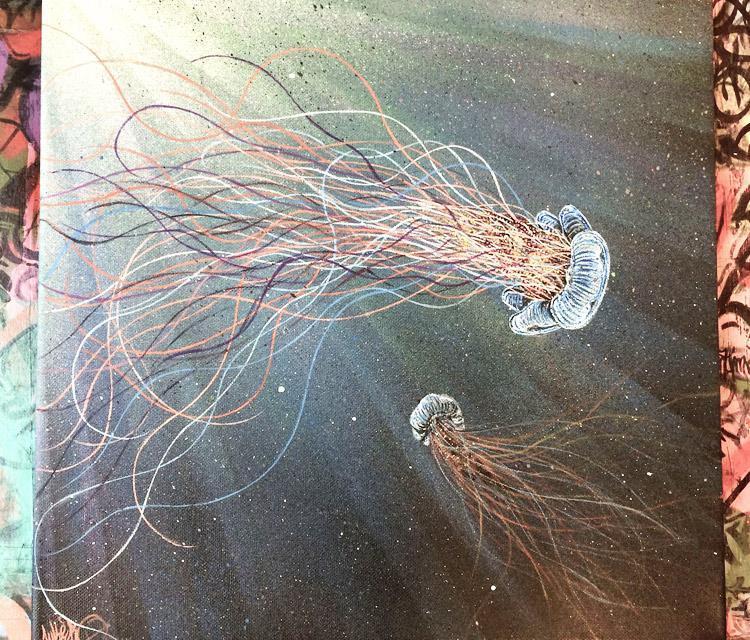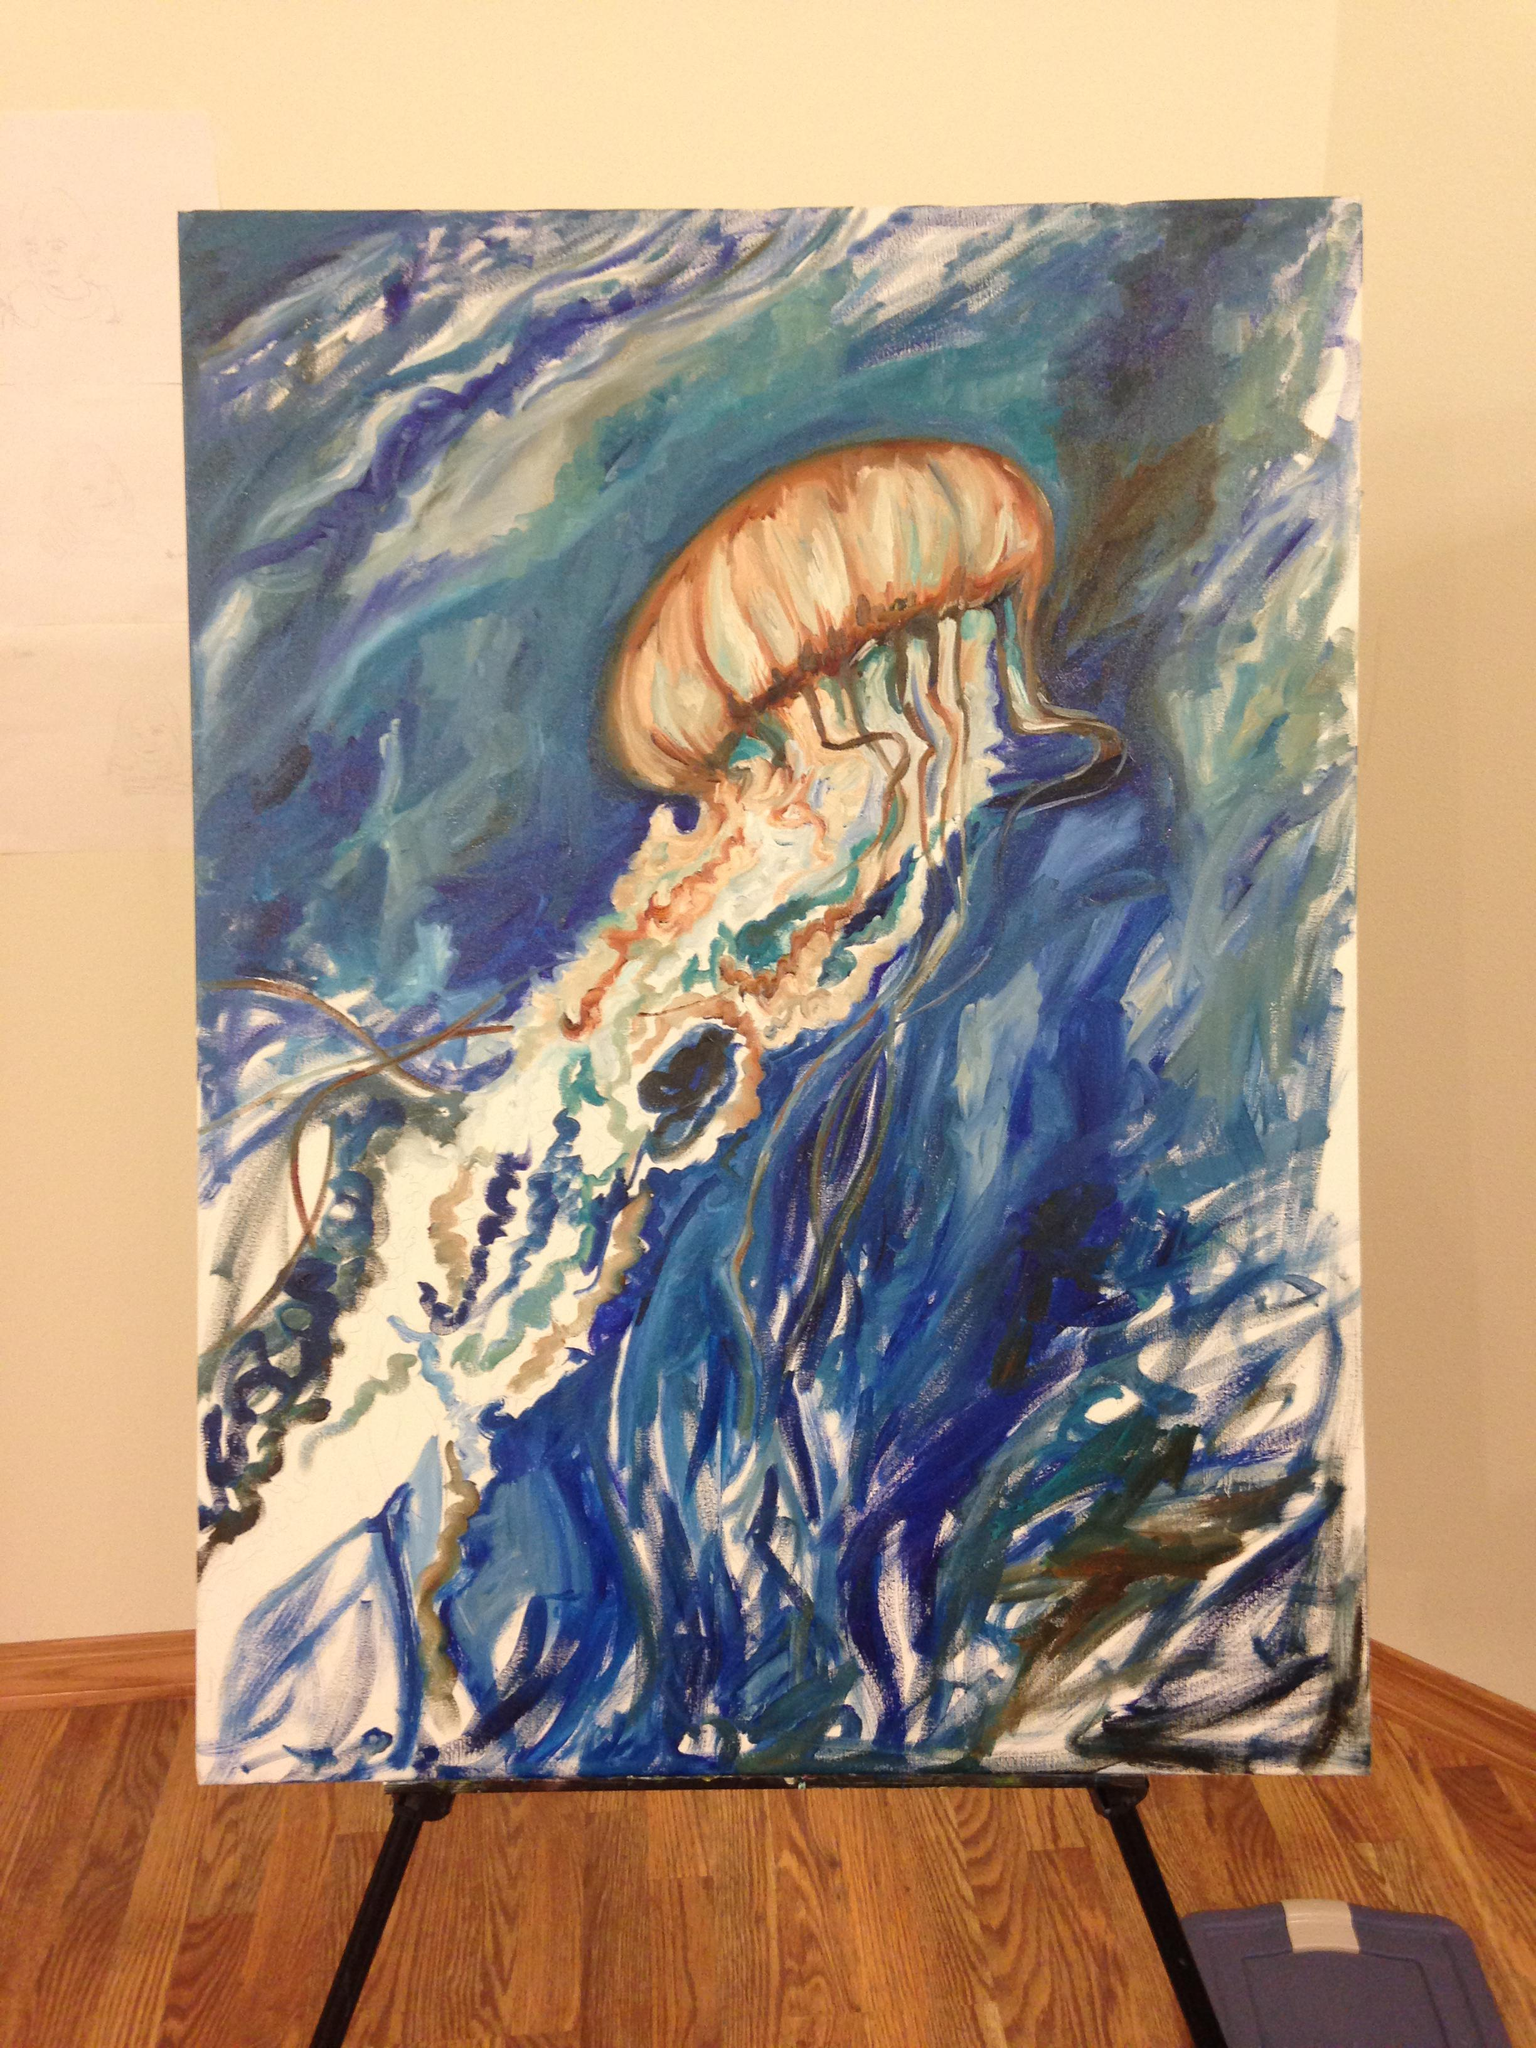The first image is the image on the left, the second image is the image on the right. Examine the images to the left and right. Is the description "An image shows a hand at the right painting a jellyfish scene." accurate? Answer yes or no. No. The first image is the image on the left, the second image is the image on the right. Considering the images on both sides, is "A person is painting a picture of jellyfish in one of the images." valid? Answer yes or no. No. 